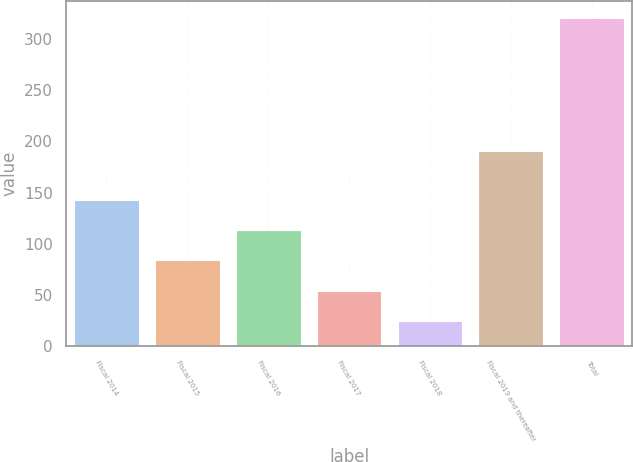<chart> <loc_0><loc_0><loc_500><loc_500><bar_chart><fcel>Fiscal 2014<fcel>Fiscal 2015<fcel>Fiscal 2016<fcel>Fiscal 2017<fcel>Fiscal 2018<fcel>Fiscal 2019 and thereafter<fcel>Total<nl><fcel>142.94<fcel>83.72<fcel>113.33<fcel>54.11<fcel>24.5<fcel>190.8<fcel>320.6<nl></chart> 